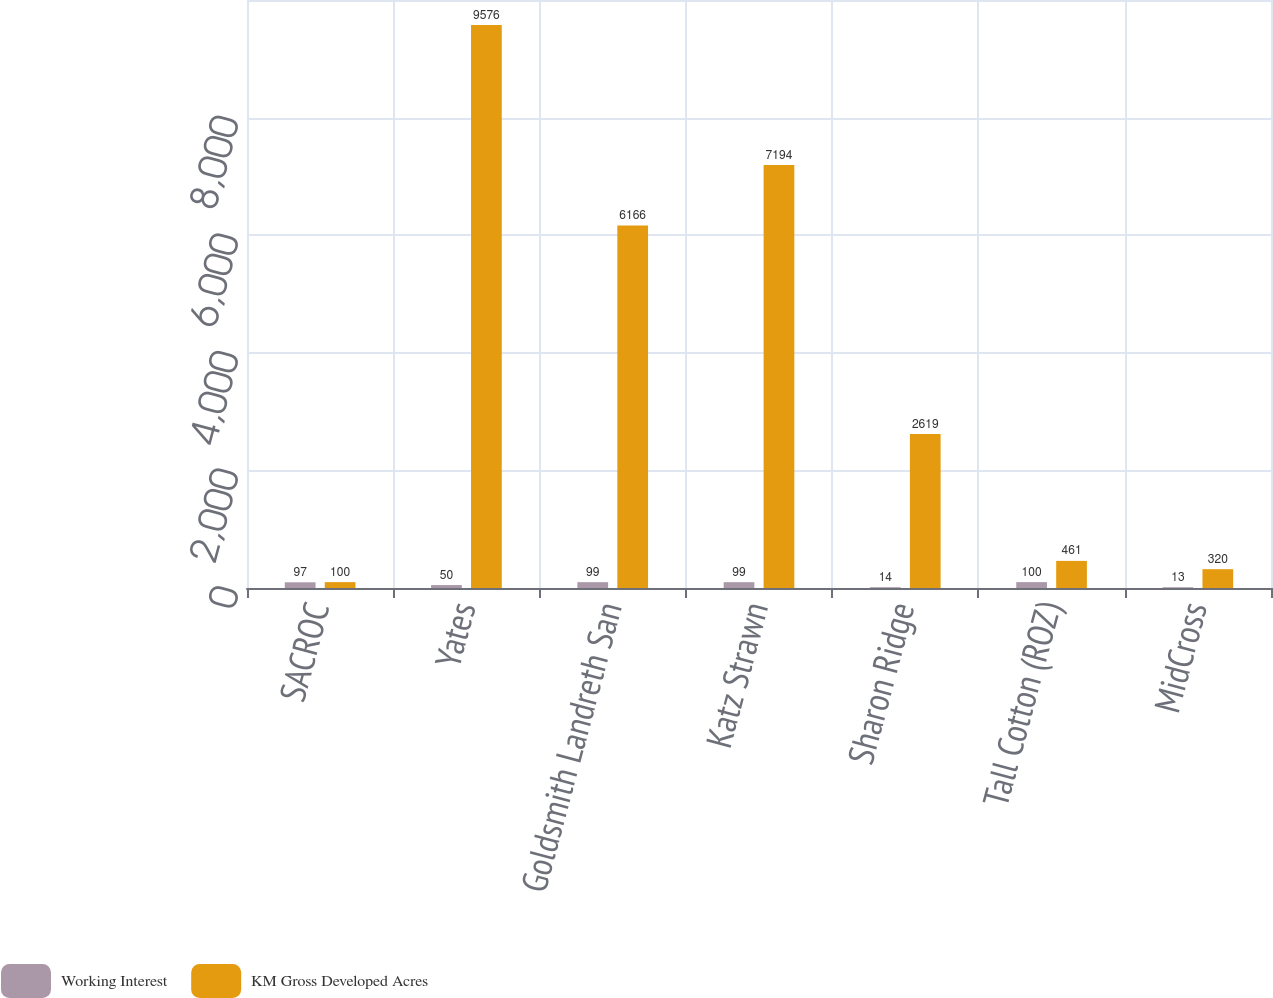<chart> <loc_0><loc_0><loc_500><loc_500><stacked_bar_chart><ecel><fcel>SACROC<fcel>Yates<fcel>Goldsmith Landreth San<fcel>Katz Strawn<fcel>Sharon Ridge<fcel>Tall Cotton (ROZ)<fcel>MidCross<nl><fcel>Working Interest<fcel>97<fcel>50<fcel>99<fcel>99<fcel>14<fcel>100<fcel>13<nl><fcel>KM Gross Developed Acres<fcel>100<fcel>9576<fcel>6166<fcel>7194<fcel>2619<fcel>461<fcel>320<nl></chart> 